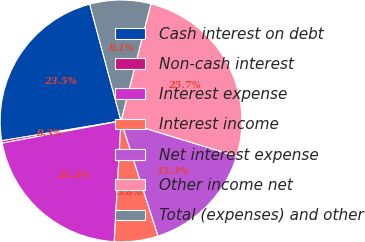Convert chart. <chart><loc_0><loc_0><loc_500><loc_500><pie_chart><fcel>Cash interest on debt<fcel>Non-cash interest<fcel>Interest expense<fcel>Interest income<fcel>Net interest expense<fcel>Other income net<fcel>Total (expenses) and other<nl><fcel>23.46%<fcel>0.32%<fcel>21.17%<fcel>5.85%<fcel>15.32%<fcel>25.75%<fcel>8.14%<nl></chart> 